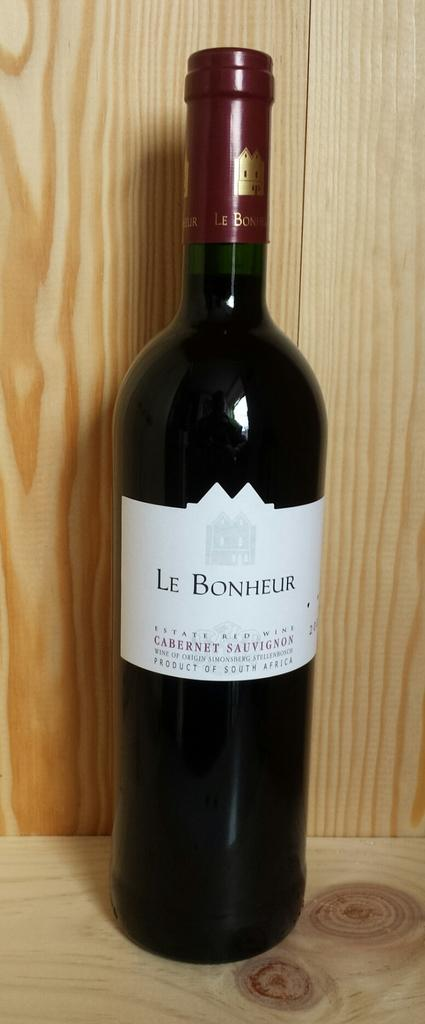<image>
Relay a brief, clear account of the picture shown. Bottle of Le Bonheur red wine that is new 